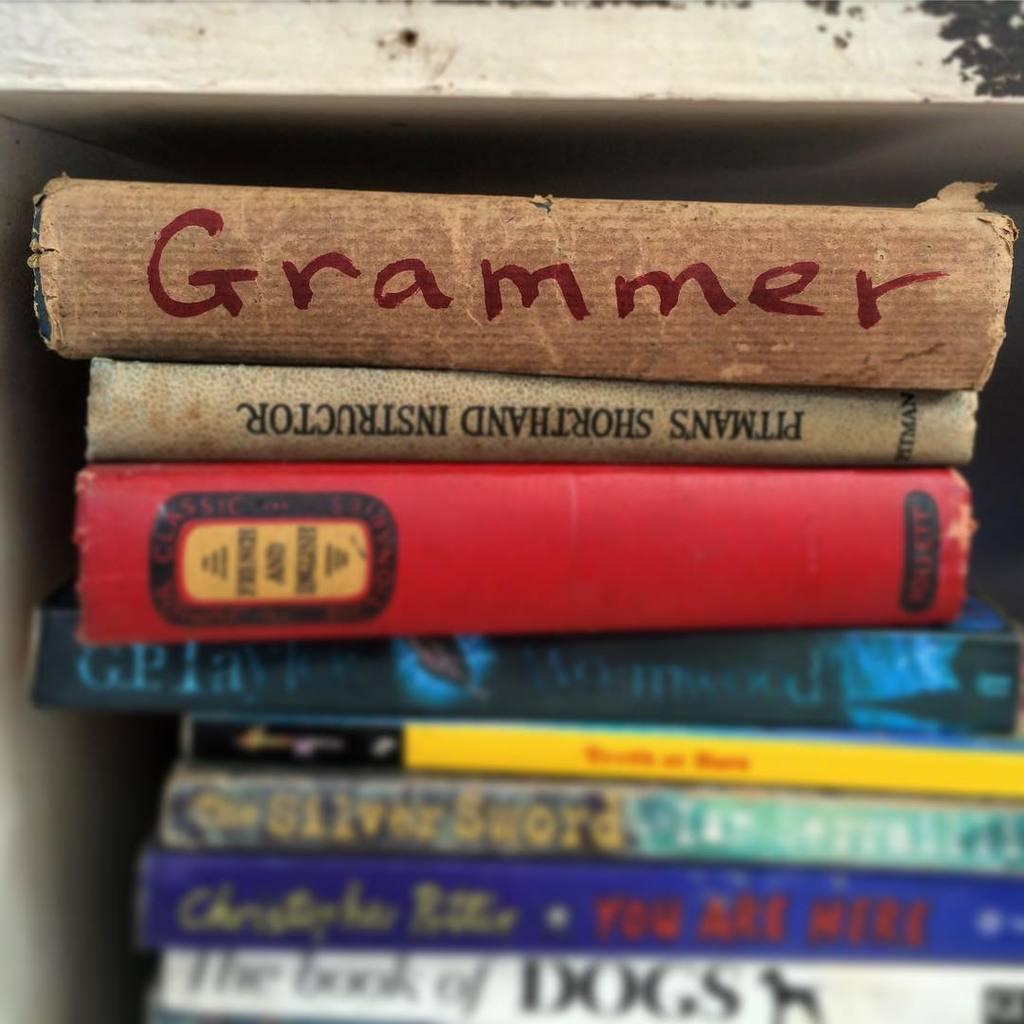<image>
Relay a brief, clear account of the picture shown. A stack of books with the top one titled Grammer. 